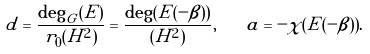<formula> <loc_0><loc_0><loc_500><loc_500>d = \frac { \deg _ { G } ( E ) } { r _ { 0 } ( H ^ { 2 } ) } = \frac { \deg ( E ( - \beta ) ) } { ( H ^ { 2 } ) } , \quad a = - \chi ( E ( - \beta ) ) .</formula> 